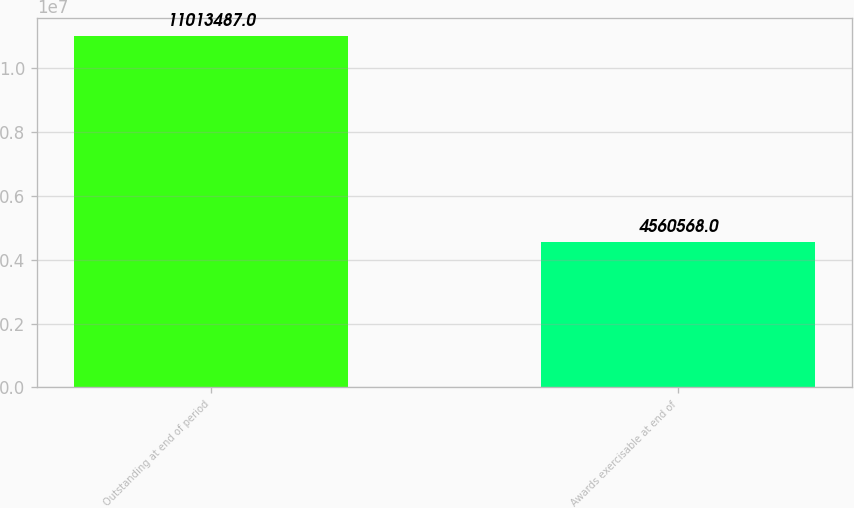Convert chart to OTSL. <chart><loc_0><loc_0><loc_500><loc_500><bar_chart><fcel>Outstanding at end of period<fcel>Awards exercisable at end of<nl><fcel>1.10135e+07<fcel>4.56057e+06<nl></chart> 